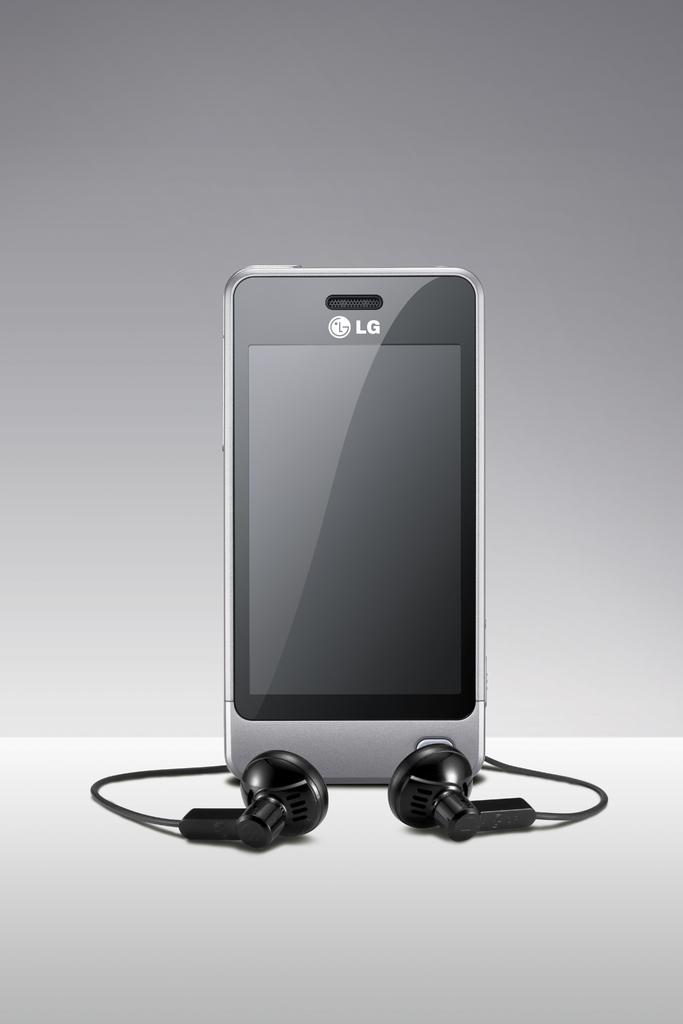<image>
Offer a succinct explanation of the picture presented. An LG brand cell phone has earbuds that attach to it. 